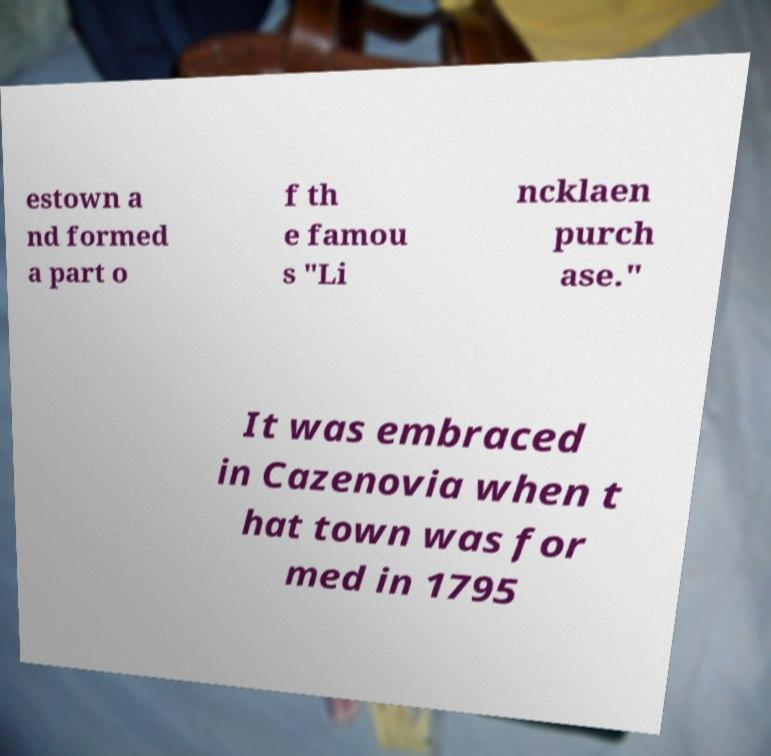Could you assist in decoding the text presented in this image and type it out clearly? estown a nd formed a part o f th e famou s "Li ncklaen purch ase." It was embraced in Cazenovia when t hat town was for med in 1795 